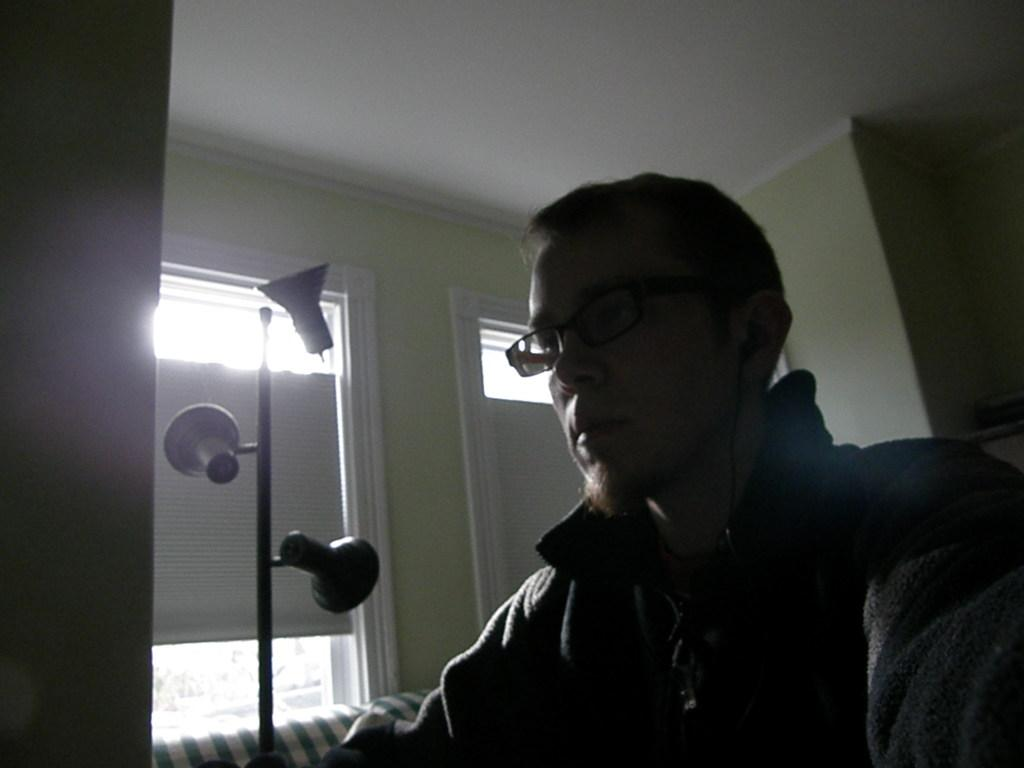Who is present on the right side of the image? There is a person on the right side of the image. What can be observed about the person's appearance? The person is wearing spectacles. What is the person's posture in the image? The person is sitting. What type of architectural feature is visible in the background of the image? There are glass windows in the background of the image. What color is the ceiling in the image? The ceiling in the image is white. What type of button does the person on the right side of the image have on their shirt? There is no button visible on the person's shirt in the image. What thought is the person on the right side of the image having? The image does not provide any information about the person's thoughts, so it cannot be determined from the image. 